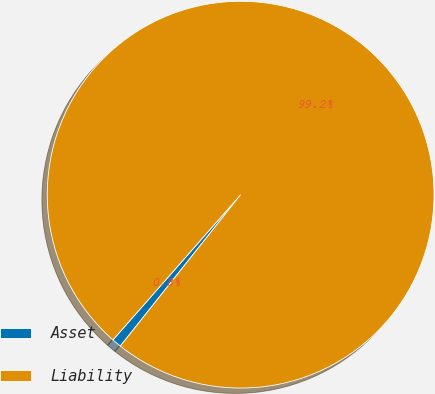Convert chart. <chart><loc_0><loc_0><loc_500><loc_500><pie_chart><fcel>Asset<fcel>Liability<nl><fcel>0.79%<fcel>99.21%<nl></chart> 